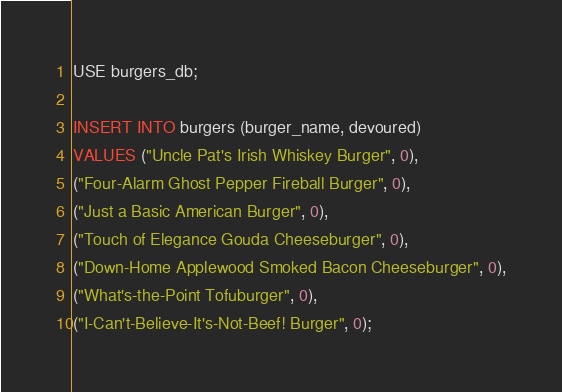Convert code to text. <code><loc_0><loc_0><loc_500><loc_500><_SQL_>USE burgers_db;

INSERT INTO burgers (burger_name, devoured)
VALUES ("Uncle Pat's Irish Whiskey Burger", 0),
("Four-Alarm Ghost Pepper Fireball Burger", 0),
("Just a Basic American Burger", 0),
("Touch of Elegance Gouda Cheeseburger", 0),
("Down-Home Applewood Smoked Bacon Cheeseburger", 0),
("What's-the-Point Tofuburger", 0),
("I-Can't-Believe-It's-Not-Beef! Burger", 0);</code> 